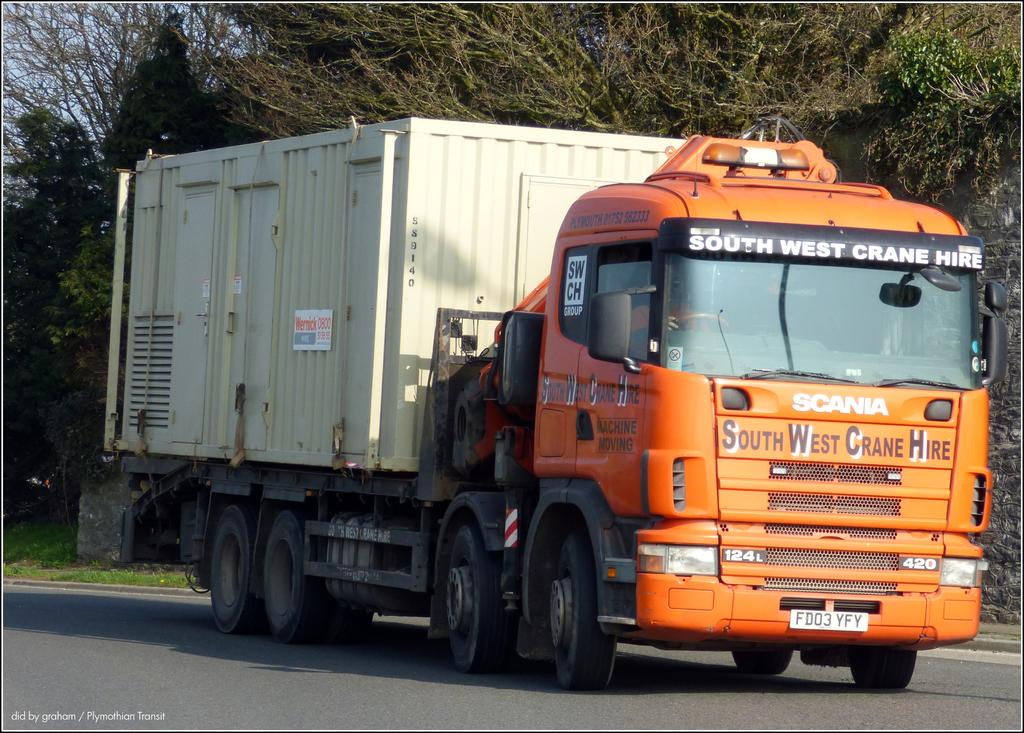What is the person in the image doing? There is a person driving a vehicle in the image. Where is the vehicle located? The vehicle is on the road. What can be seen in the background of the image? There are trees and sky visible in the background of the image. Is there any text present in the image? Yes, there is some text at the bottom of the image. What type of eggnog is being served in the vehicle in the image? There is no eggnog present in the image; it features a person driving a vehicle on the road. What unit of measurement is used to describe the size of the ring in the image? There is no ring present in the image. 